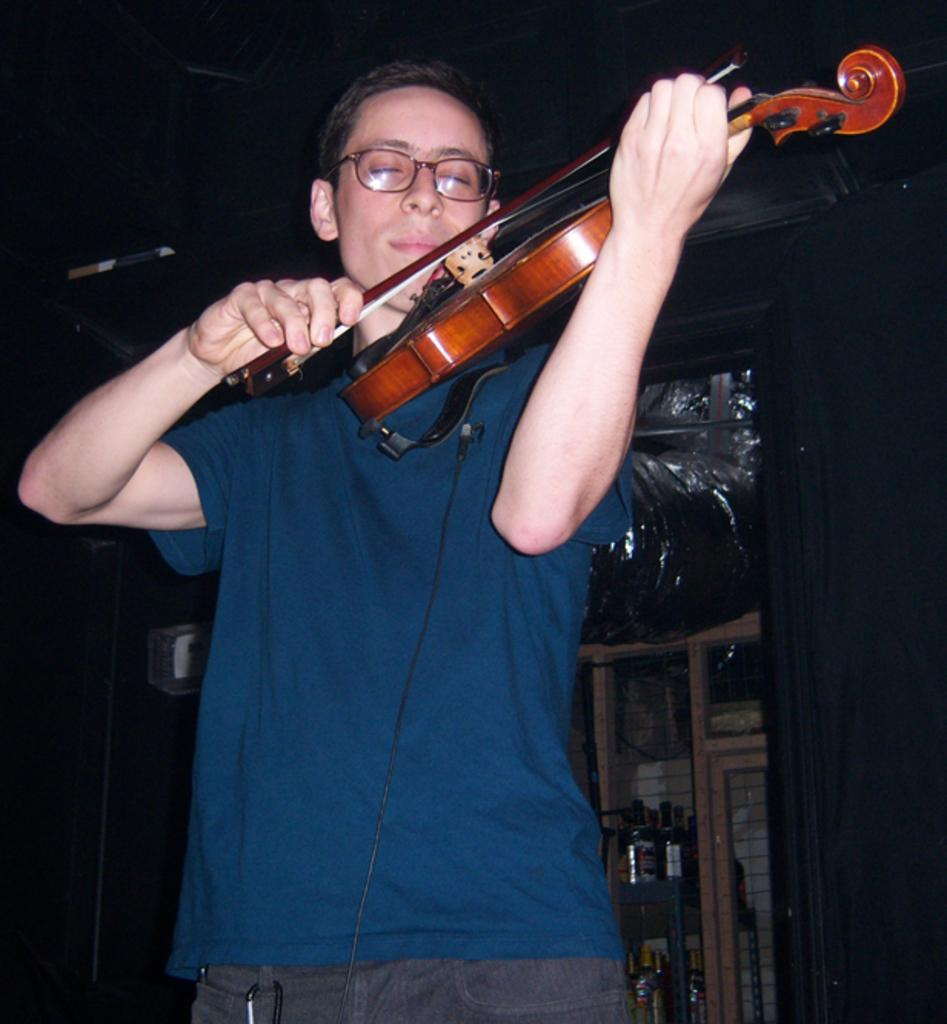Who is the main subject in the image? There is a boy in the image. What is the boy wearing? The boy is wearing a blue shirt. What is the boy holding in the image? The boy is holding a guitar. What can be seen on the wall in the image? There is a shelf on the wall in the image. What is placed on the shelf? Bottles are placed on the shelf. What type of boot is hanging from the ceiling in the image? There is no boot hanging from the ceiling in the image. 